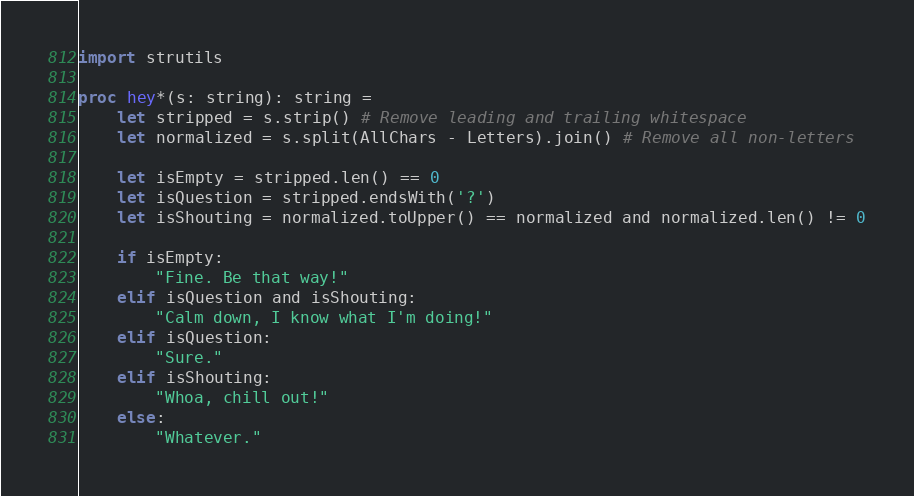Convert code to text. <code><loc_0><loc_0><loc_500><loc_500><_Nim_>import strutils

proc hey*(s: string): string =
    let stripped = s.strip() # Remove leading and trailing whitespace
    let normalized = s.split(AllChars - Letters).join() # Remove all non-letters
    
    let isEmpty = stripped.len() == 0
    let isQuestion = stripped.endsWith('?')
    let isShouting = normalized.toUpper() == normalized and normalized.len() != 0

    if isEmpty:
        "Fine. Be that way!"
    elif isQuestion and isShouting:
        "Calm down, I know what I'm doing!"
    elif isQuestion:
        "Sure."
    elif isShouting:
        "Whoa, chill out!"
    else:
        "Whatever."</code> 